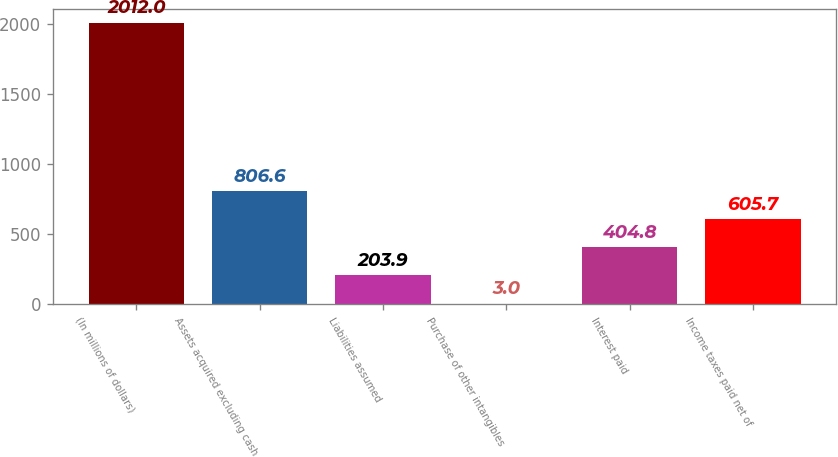Convert chart. <chart><loc_0><loc_0><loc_500><loc_500><bar_chart><fcel>(In millions of dollars)<fcel>Assets acquired excluding cash<fcel>Liabilities assumed<fcel>Purchase of other intangibles<fcel>Interest paid<fcel>Income taxes paid net of<nl><fcel>2012<fcel>806.6<fcel>203.9<fcel>3<fcel>404.8<fcel>605.7<nl></chart> 